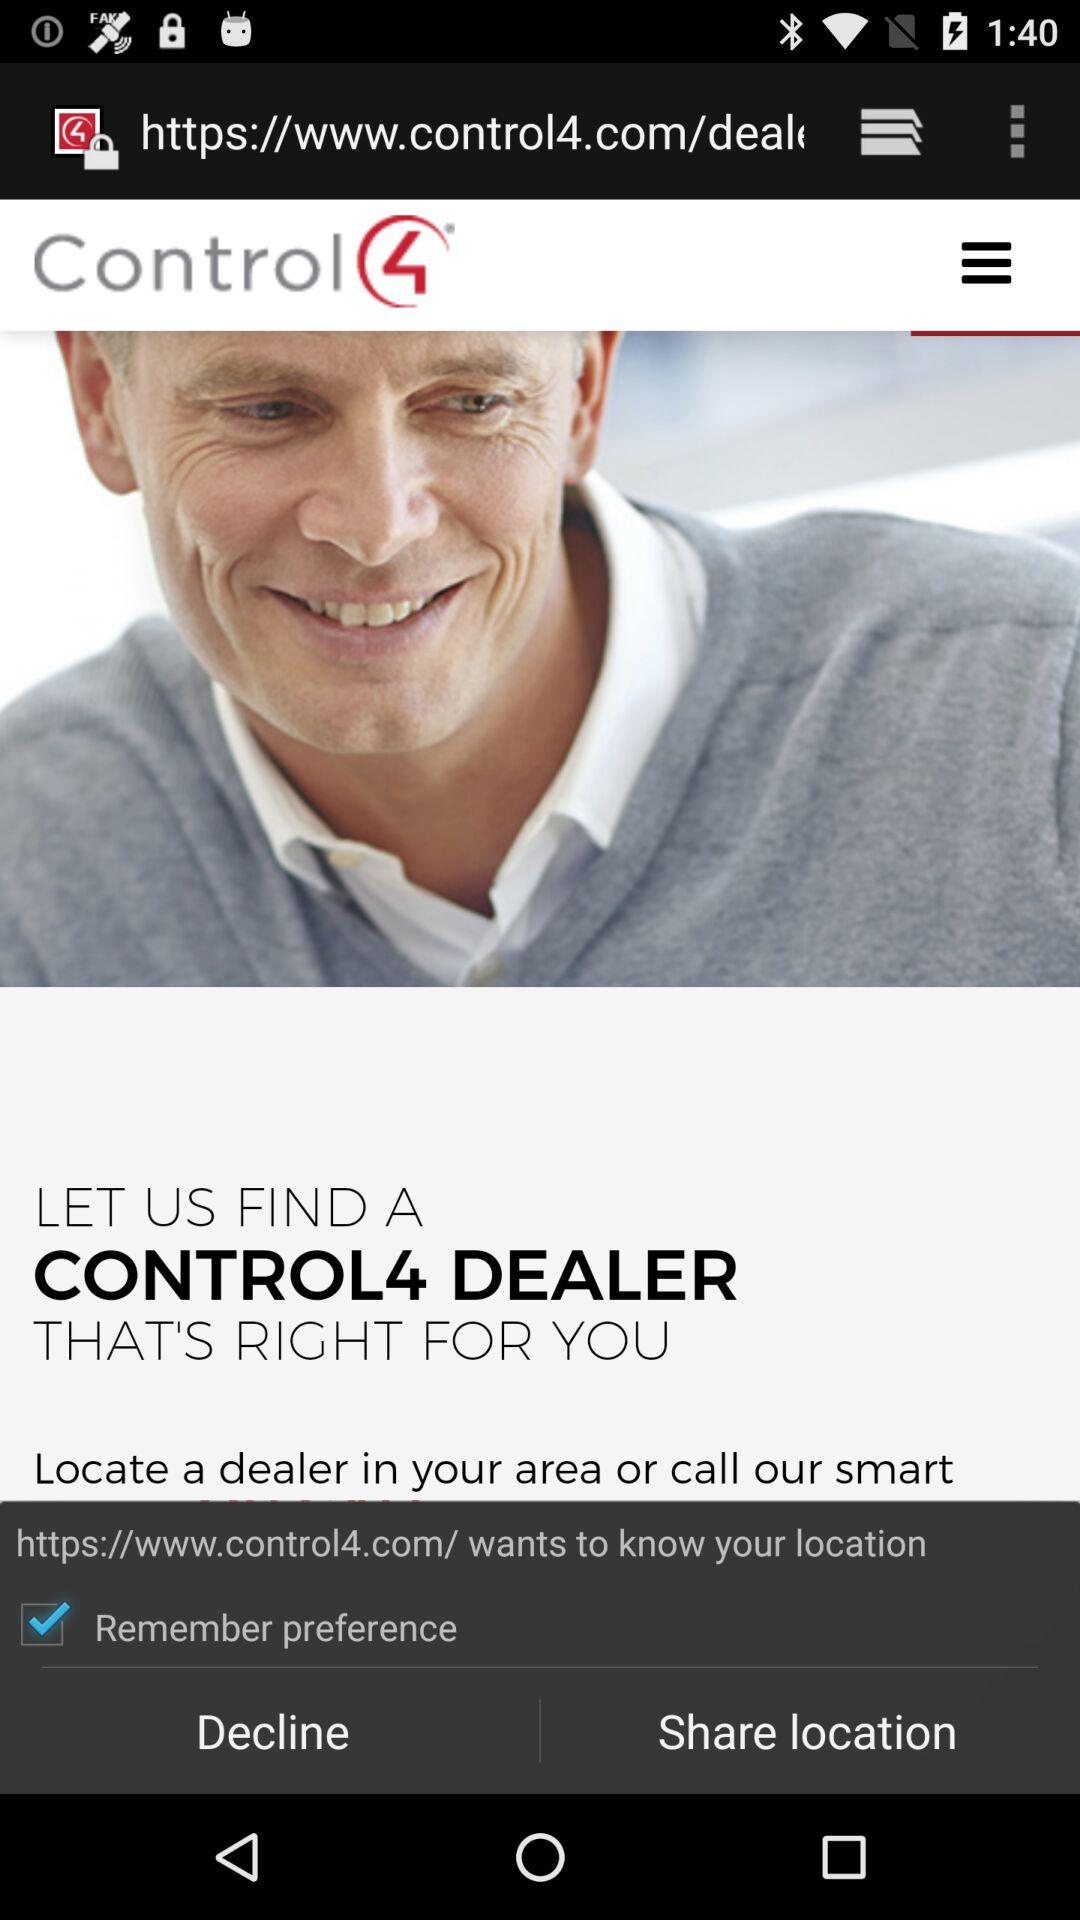What website wants to know my location? The website is https://www.control4.com/. 